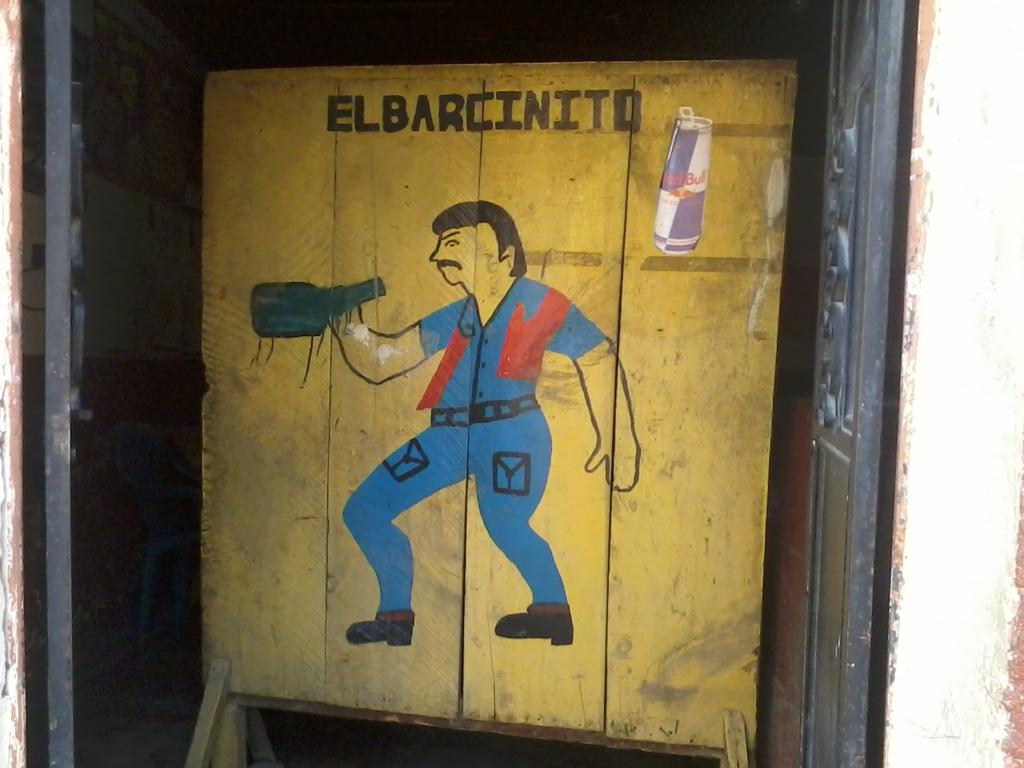What do the black letters read?
Offer a terse response. Elbarcinito. What does it say on the can?
Your response must be concise. Red bull. 